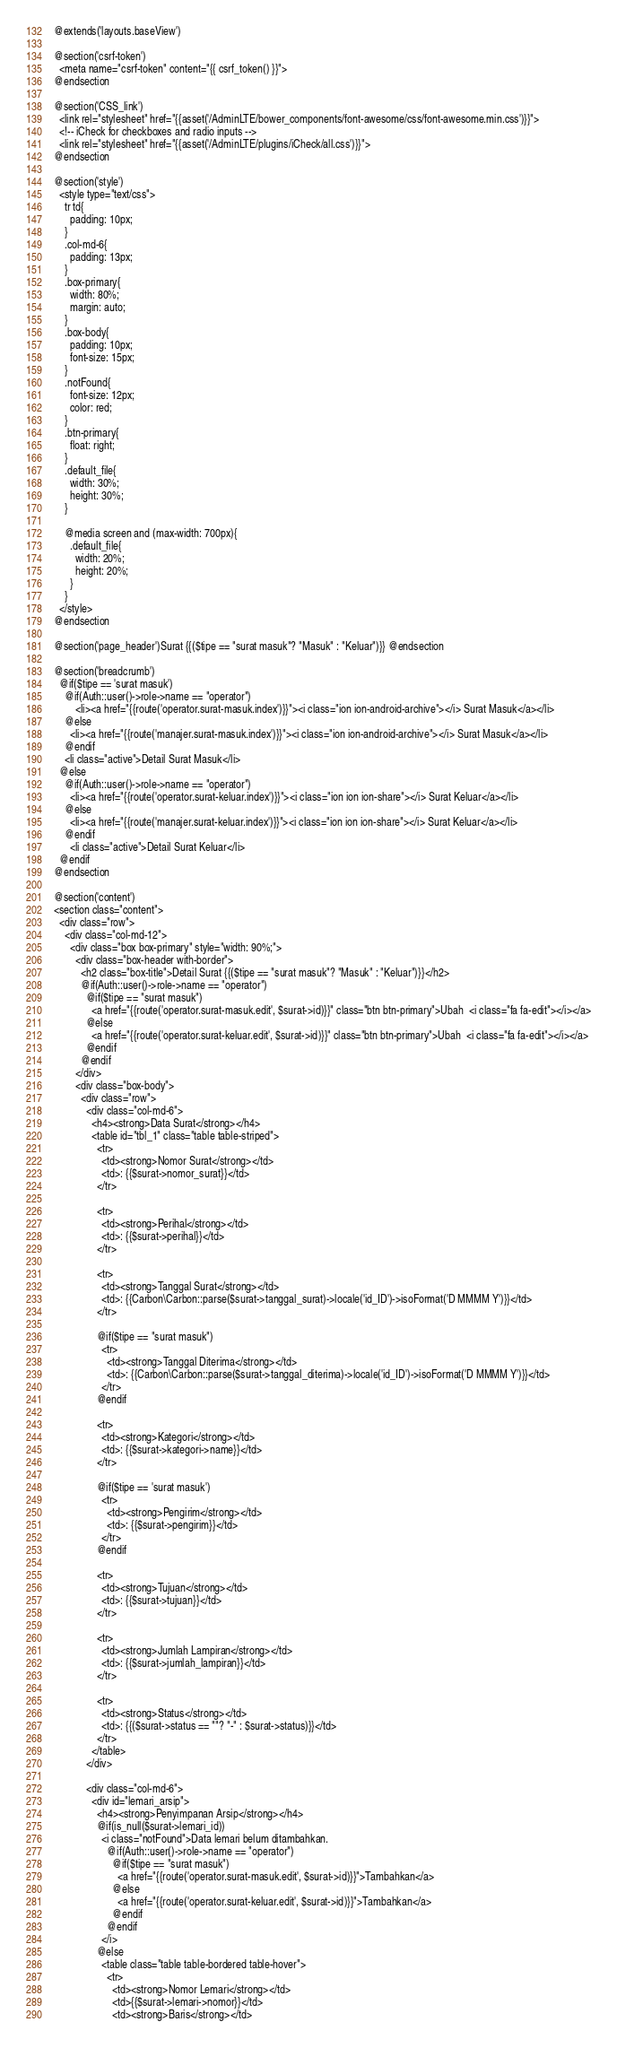<code> <loc_0><loc_0><loc_500><loc_500><_PHP_>@extends('layouts.baseView')

@section('csrf-token')
  <meta name="csrf-token" content="{{ csrf_token() }}">
@endsection

@section('CSS_link')
  <link rel="stylesheet" href="{{asset('/AdminLTE/bower_components/font-awesome/css/font-awesome.min.css')}}">
  <!-- iCheck for checkboxes and radio inputs -->
  <link rel="stylesheet" href="{{asset('/AdminLTE/plugins/iCheck/all.css')}}">
@endsection

@section('style')
  <style type="text/css">
    tr td{
      padding: 10px;
    }
    .col-md-6{
      padding: 13px;
    }
    .box-primary{
      width: 80%;
      margin: auto;
    }
    .box-body{
      padding: 10px;
      font-size: 15px;
    }
    .notFound{
      font-size: 12px;
      color: red;
    }
    .btn-primary{
      float: right;
    }
    .default_file{
      width: 30%;
      height: 30%;
    }

    @media screen and (max-width: 700px){
      .default_file{
        width: 20%;
        height: 20%;
      } 
    }
  </style>
@endsection

@section('page_header')Surat {{($tipe == "surat masuk"? "Masuk" : "Keluar")}} @endsection

@section('breadcrumb')
  @if($tipe == 'surat masuk')
    @if(Auth::user()->role->name == "operator")
    	<li><a href="{{route('operator.surat-masuk.index')}}"><i class="ion ion-android-archive"></i> Surat Masuk</a></li>
    @else
      <li><a href="{{route('manajer.surat-masuk.index')}}"><i class="ion ion-android-archive"></i> Surat Masuk</a></li>
    @endif
  	<li class="active">Detail Surat Masuk</li>
  @else
    @if(Auth::user()->role->name == "operator")
      <li><a href="{{route('operator.surat-keluar.index')}}"><i class="ion ion ion-share"></i> Surat Keluar</a></li>
    @else
      <li><a href="{{route('manajer.surat-keluar.index')}}"><i class="ion ion ion-share"></i> Surat Keluar</a></li>
    @endif
      <li class="active">Detail Surat Keluar</li>
  @endif
@endsection

@section('content')
<section class="content">
  <div class="row">
    <div class="col-md-12">
      <div class="box box-primary" style="width: 90%;">
        <div class="box-header with-border">
          <h2 class="box-title">Detail Surat {{($tipe == "surat masuk"? "Masuk" : "Keluar")}}</h2>
          @if(Auth::user()->role->name == "operator")
            @if($tipe == "surat masuk")
              <a href="{{route('operator.surat-masuk.edit', $surat->id)}}" class="btn btn-primary">Ubah  <i class="fa fa-edit"></i></a>
            @else
              <a href="{{route('operator.surat-keluar.edit', $surat->id)}}" class="btn btn-primary">Ubah  <i class="fa fa-edit"></i></a>
            @endif
          @endif
        </div>
        <div class="box-body">
          <div class="row">
            <div class="col-md-6">
              <h4><strong>Data Surat</strong></h4>
              <table id="tbl_1" class="table table-striped">
                <tr>
                  <td><strong>Nomor Surat</strong></td>
                  <td>: {{$surat->nomor_surat}}</td>
                </tr>

                <tr>
                  <td><strong>Perihal</strong></td>
                  <td>: {{$surat->perihal}}</td>
                </tr>

                <tr>
                  <td><strong>Tanggal Surat</strong></td>
                  <td>: {{Carbon\Carbon::parse($surat->tanggal_surat)->locale('id_ID')->isoFormat('D MMMM Y')}}</td>
                </tr>

                @if($tipe == "surat masuk")
                  <tr>
                    <td><strong>Tanggal Diterima</strong></td>
                    <td>: {{Carbon\Carbon::parse($surat->tanggal_diterima)->locale('id_ID')->isoFormat('D MMMM Y')}}</td>
                  </tr>
                @endif

                <tr>
                  <td><strong>Kategori</strong></td>
                  <td>: {{$surat->kategori->name}}</td>
                </tr>

                @if($tipe == 'surat masuk')
                  <tr>
                    <td><strong>Pengirim</strong></td>
                    <td>: {{$surat->pengirim}}</td>
                  </tr>
                @endif

                <tr>
                  <td><strong>Tujuan</strong></td>
                  <td>: {{$surat->tujuan}}</td>
                </tr>

                <tr>
                  <td><strong>Jumlah Lampiran</strong></td>
                  <td>: {{$surat->jumlah_lampiran}}</td>
                </tr>

                <tr>
                  <td><strong>Status</strong></td>
                  <td>: {{($surat->status == ""? "-" : $surat->status)}}</td>
                </tr>
              </table>
            </div>

            <div class="col-md-6">
              <div id="lemari_arsip">
                <h4><strong>Penyimpanan Arsip</strong></h4>
                @if(is_null($surat->lemari_id))
                  <i class="notFound">Data lemari belum ditambahkan. 
                    @if(Auth::user()->role->name == "operator")
                      @if($tipe == "surat masuk")
                        <a href="{{route('operator.surat-masuk.edit', $surat->id)}}">Tambahkan</a>
                      @else
                        <a href="{{route('operator.surat-keluar.edit', $surat->id)}}">Tambahkan</a>
                      @endif
                    @endif
                  </i>
                @else
                  <table class="table table-bordered table-hover">
                    <tr>
                      <td><strong>Nomor Lemari</strong></td>
                      <td>{{$surat->lemari->nomor}}</td>
                      <td><strong>Baris</strong></td></code> 